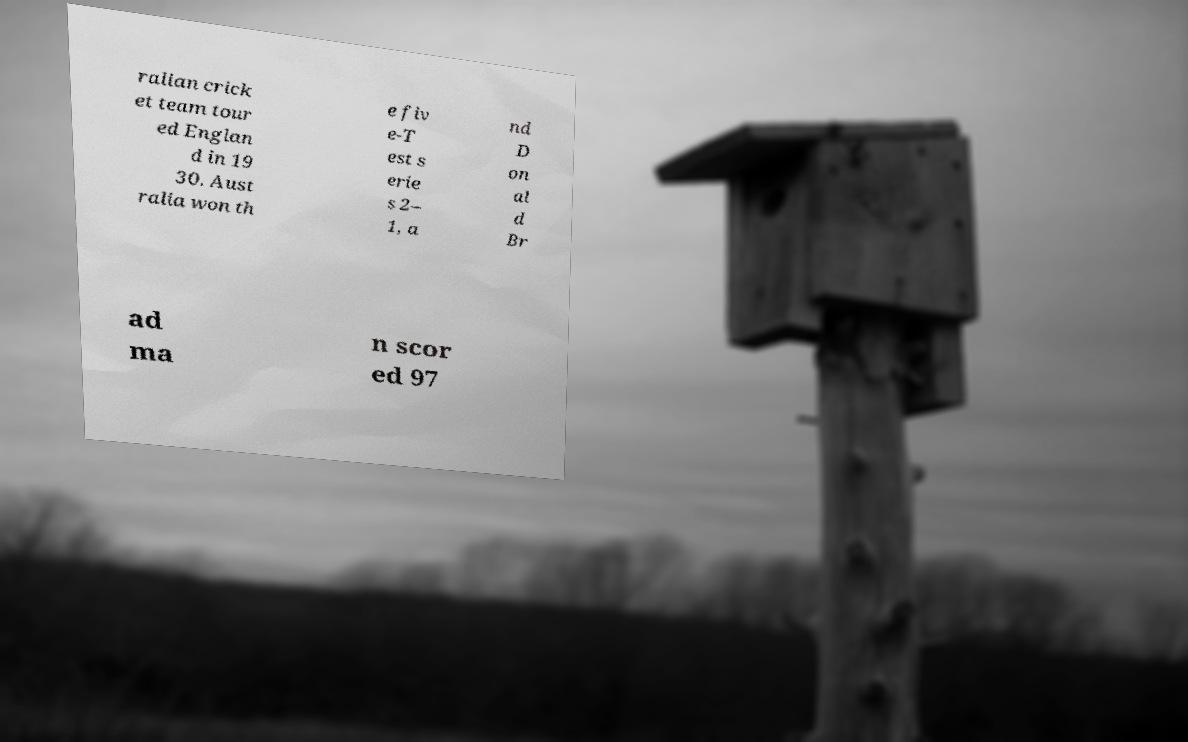Could you assist in decoding the text presented in this image and type it out clearly? ralian crick et team tour ed Englan d in 19 30. Aust ralia won th e fiv e-T est s erie s 2– 1, a nd D on al d Br ad ma n scor ed 97 